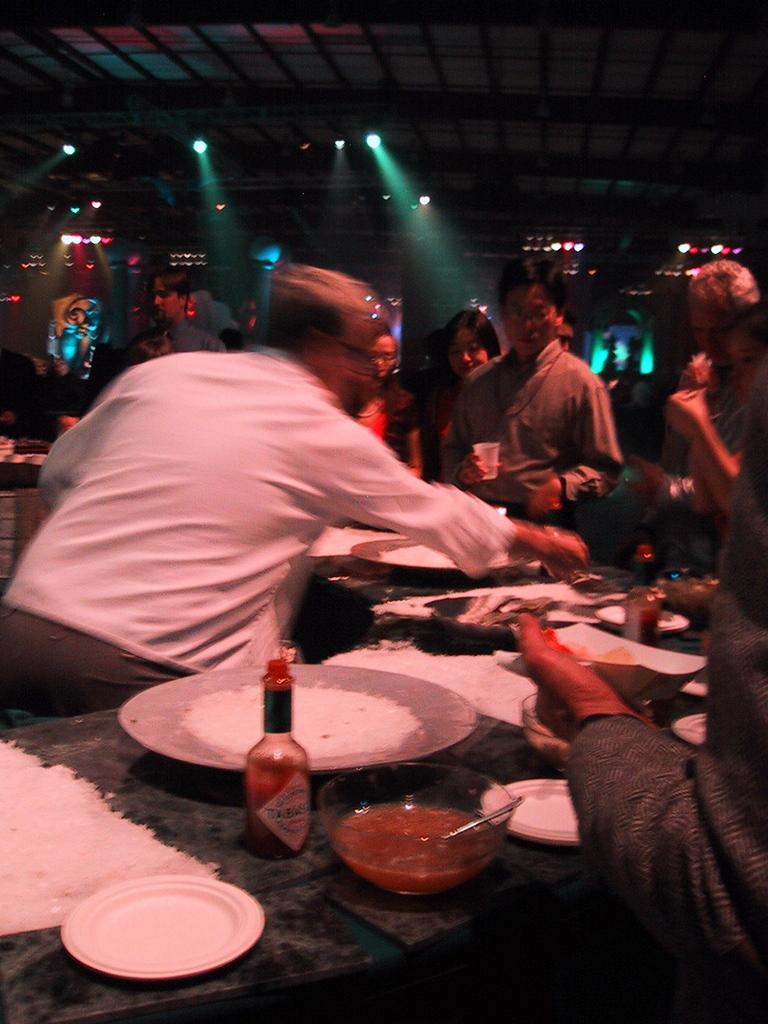In one or two sentences, can you explain what this image depicts? This picture shows a man serving food and we see some planets,some sauces on the table we see people standing in front of him holding some bowls and glasses in there hand 